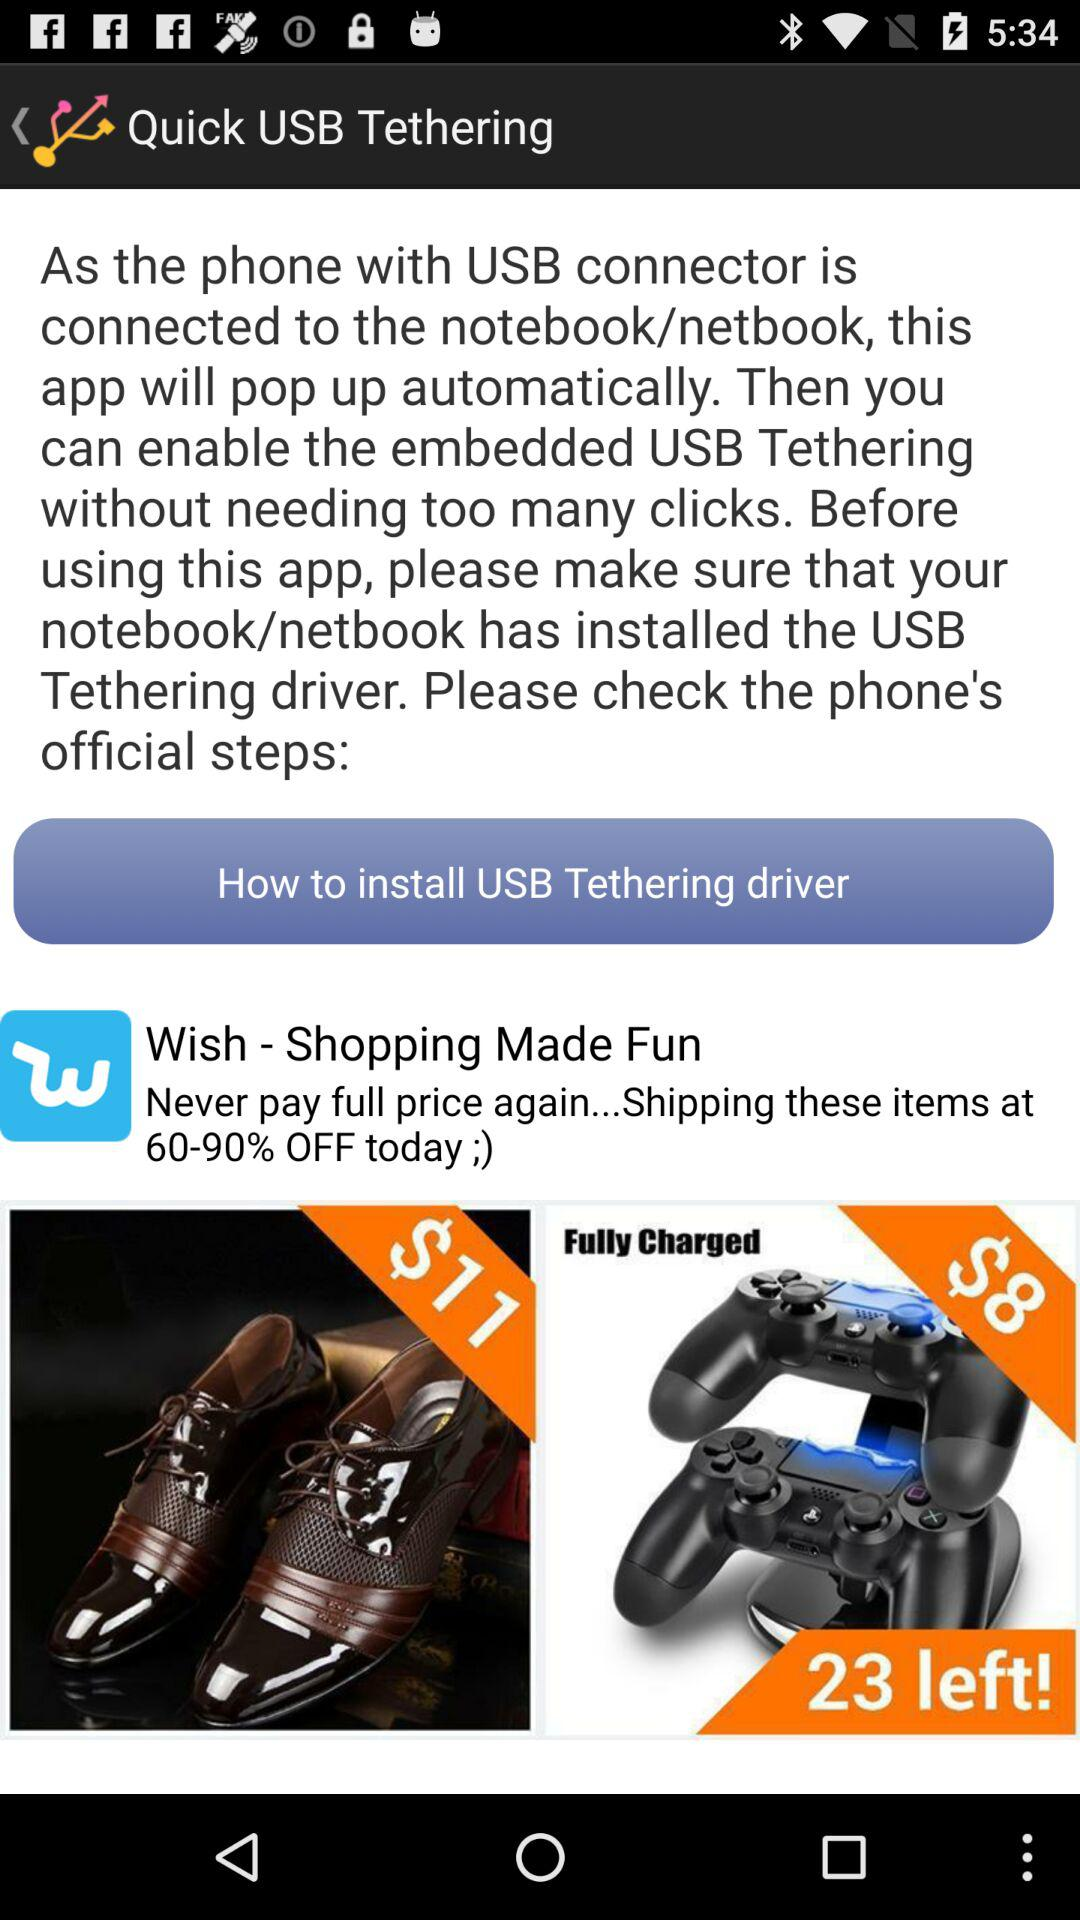How much is the playstation 4 controller holder?
Answer the question using a single word or phrase. $8 